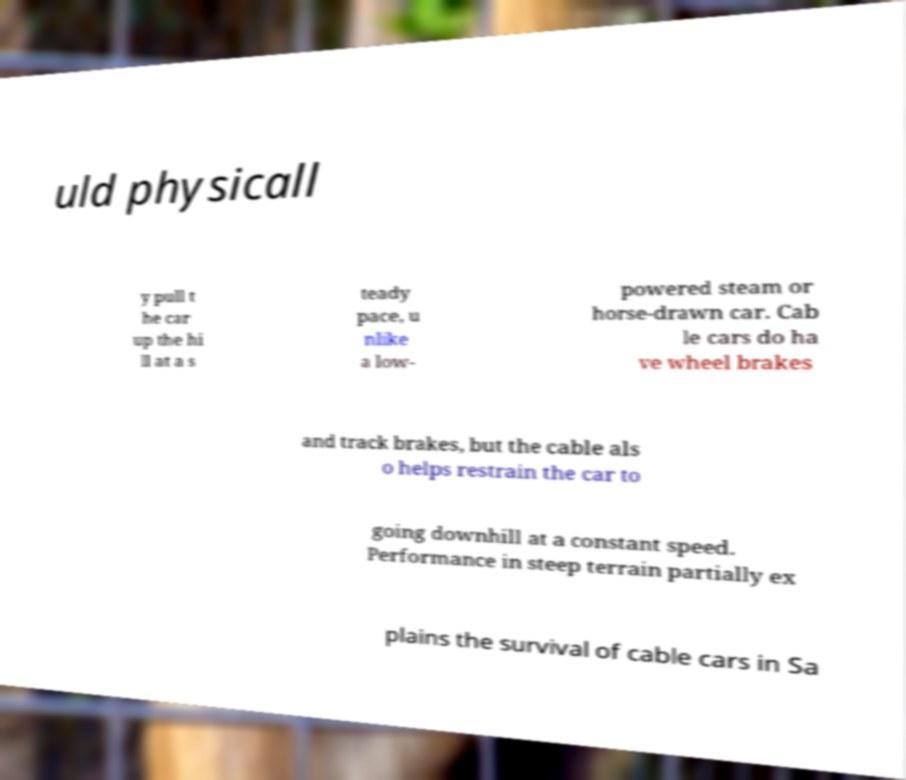For documentation purposes, I need the text within this image transcribed. Could you provide that? uld physicall y pull t he car up the hi ll at a s teady pace, u nlike a low- powered steam or horse-drawn car. Cab le cars do ha ve wheel brakes and track brakes, but the cable als o helps restrain the car to going downhill at a constant speed. Performance in steep terrain partially ex plains the survival of cable cars in Sa 